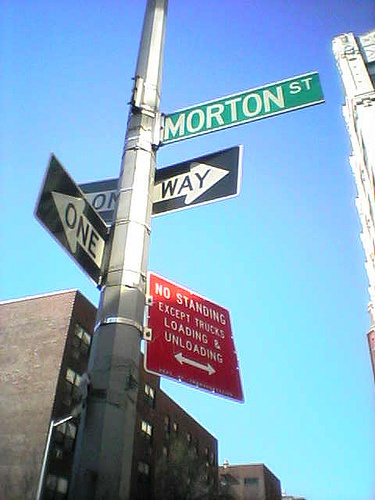Describe the objects in this image and their specific colors. I can see various objects in this image with different colors. 